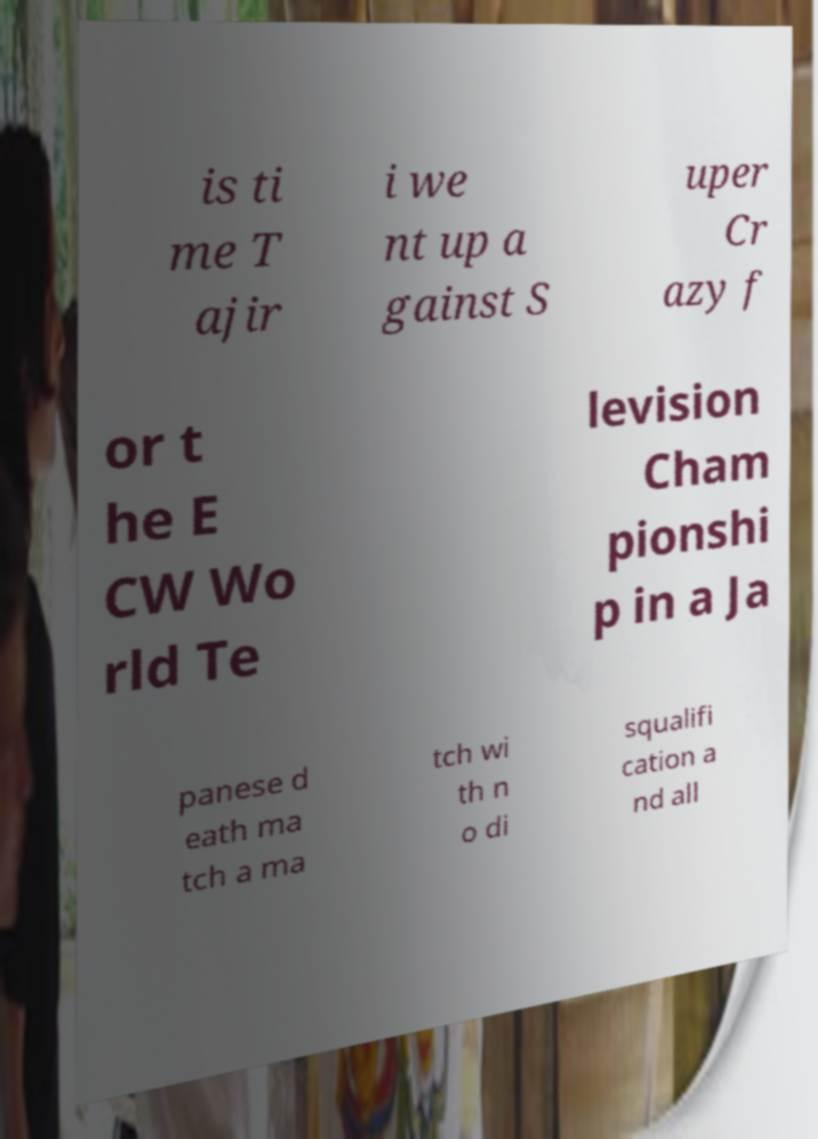Could you assist in decoding the text presented in this image and type it out clearly? is ti me T ajir i we nt up a gainst S uper Cr azy f or t he E CW Wo rld Te levision Cham pionshi p in a Ja panese d eath ma tch a ma tch wi th n o di squalifi cation a nd all 